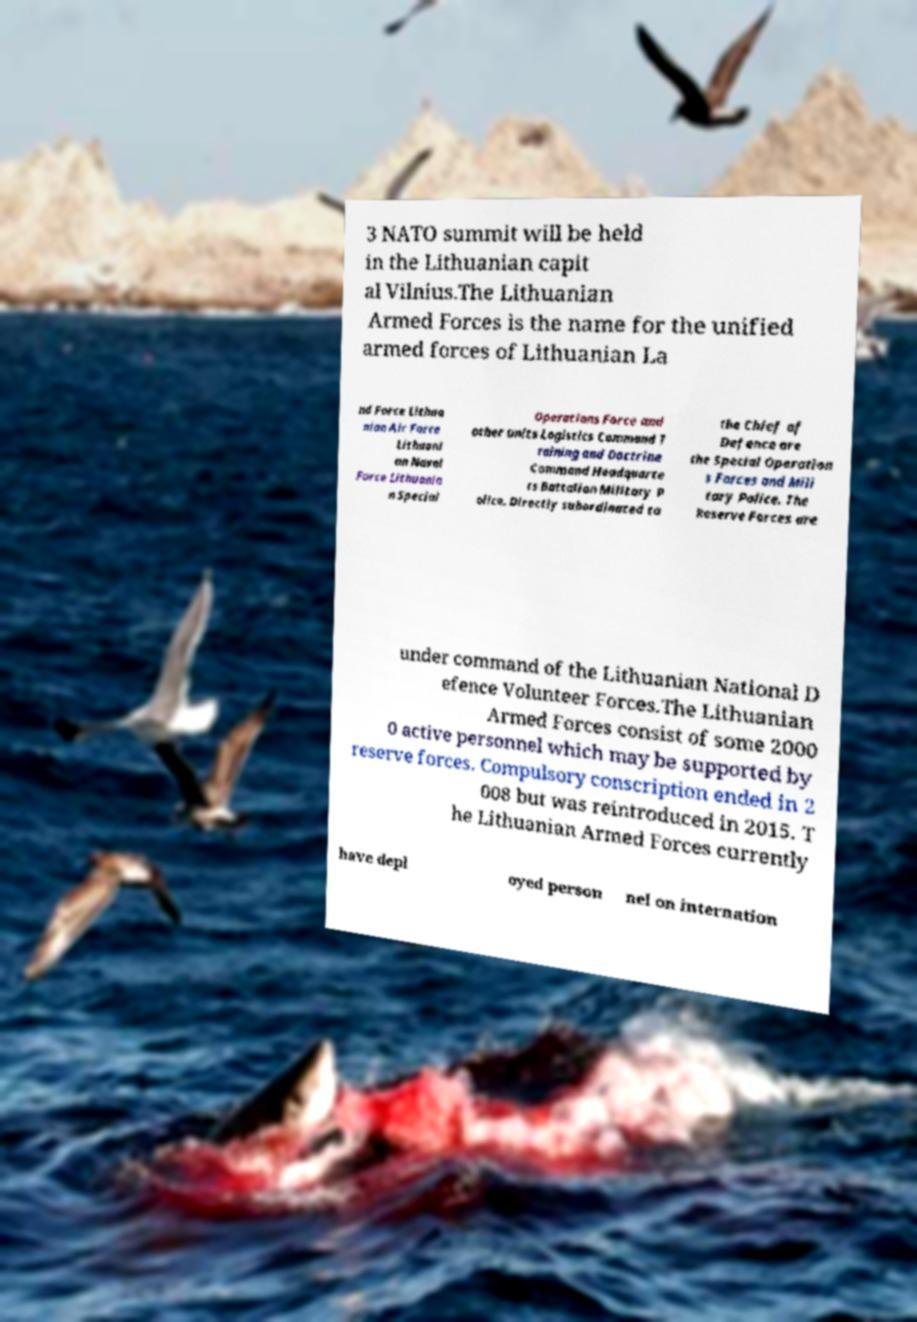Could you extract and type out the text from this image? 3 NATO summit will be held in the Lithuanian capit al Vilnius.The Lithuanian Armed Forces is the name for the unified armed forces of Lithuanian La nd Force Lithua nian Air Force Lithuani an Naval Force Lithuania n Special Operations Force and other units Logistics Command T raining and Doctrine Command Headquarte rs Battalion Military P olice. Directly subordinated to the Chief of Defence are the Special Operation s Forces and Mili tary Police. The Reserve Forces are under command of the Lithuanian National D efence Volunteer Forces.The Lithuanian Armed Forces consist of some 2000 0 active personnel which may be supported by reserve forces. Compulsory conscription ended in 2 008 but was reintroduced in 2015. T he Lithuanian Armed Forces currently have depl oyed person nel on internation 